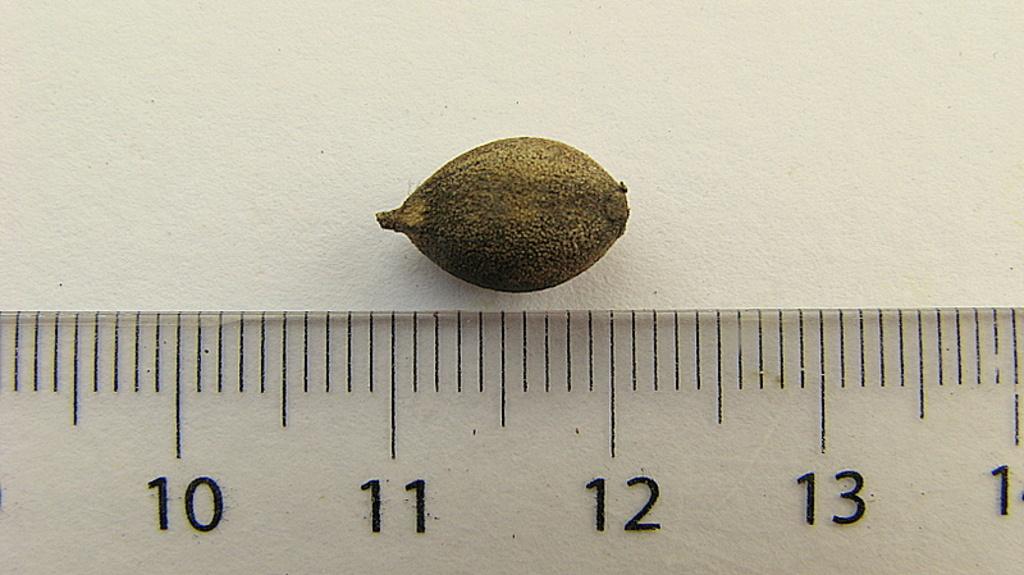What is the left most number on the ruler?
Keep it short and to the point. 10. What numbers are the seed in between on the ruler?
Ensure brevity in your answer.  11 and 12. 